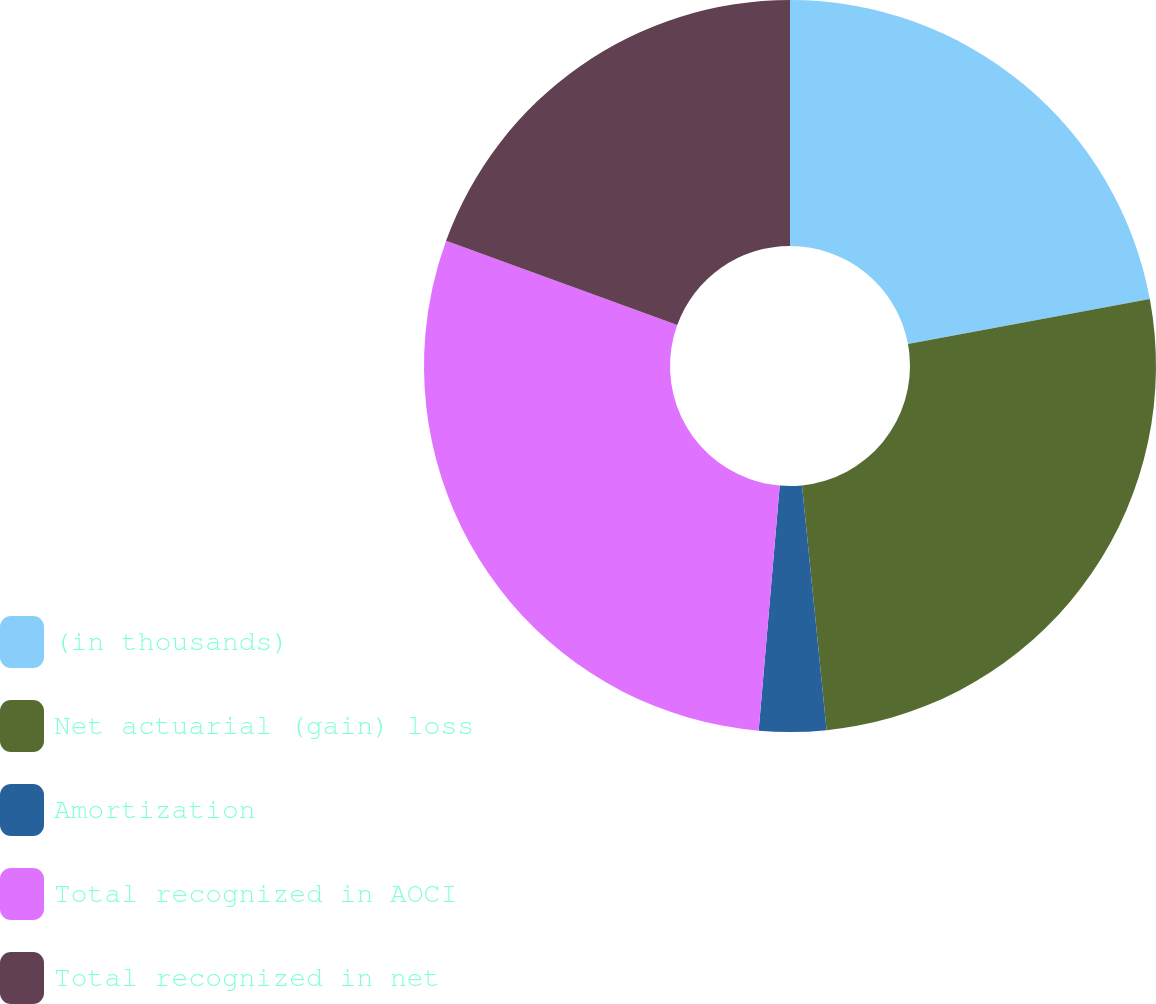Convert chart to OTSL. <chart><loc_0><loc_0><loc_500><loc_500><pie_chart><fcel>(in thousands)<fcel>Net actuarial (gain) loss<fcel>Amortization<fcel>Total recognized in AOCI<fcel>Total recognized in net<nl><fcel>22.07%<fcel>26.33%<fcel>2.96%<fcel>29.19%<fcel>19.44%<nl></chart> 